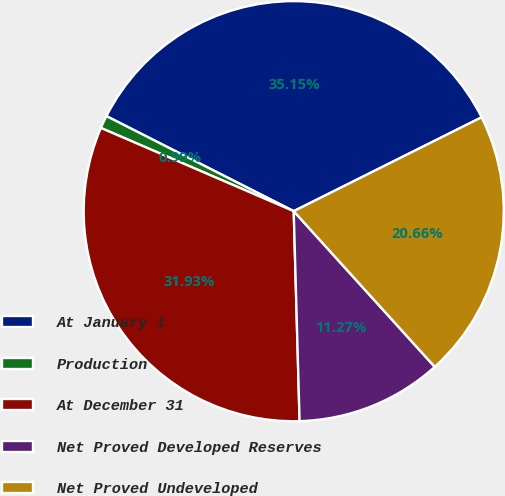Convert chart. <chart><loc_0><loc_0><loc_500><loc_500><pie_chart><fcel>At January 1<fcel>Production<fcel>At December 31<fcel>Net Proved Developed Reserves<fcel>Net Proved Undeveloped<nl><fcel>35.15%<fcel>0.99%<fcel>31.93%<fcel>11.27%<fcel>20.66%<nl></chart> 